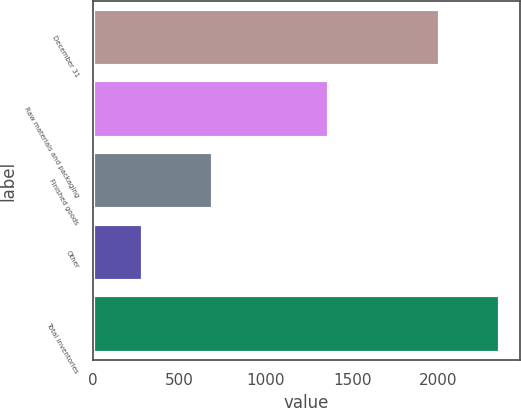Convert chart. <chart><loc_0><loc_0><loc_500><loc_500><bar_chart><fcel>December 31<fcel>Raw materials and packaging<fcel>Finished goods<fcel>Other<fcel>Total inventories<nl><fcel>2009<fcel>1366<fcel>697<fcel>291<fcel>2354<nl></chart> 